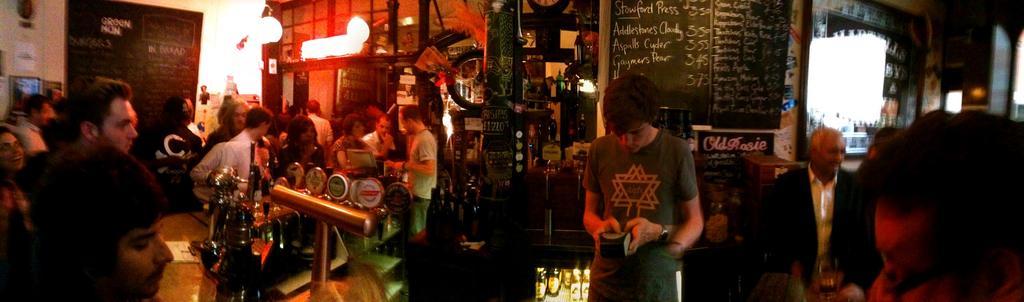Describe this image in one or two sentences. This image seems to be clicked in a bar, there are many people standing all over the place, in the middle there are tables with wine bottles,glasses on it and behind there is a black board with some text on it and there are many things on either side of it, on the left side there are lights hanging to the ceiling. 